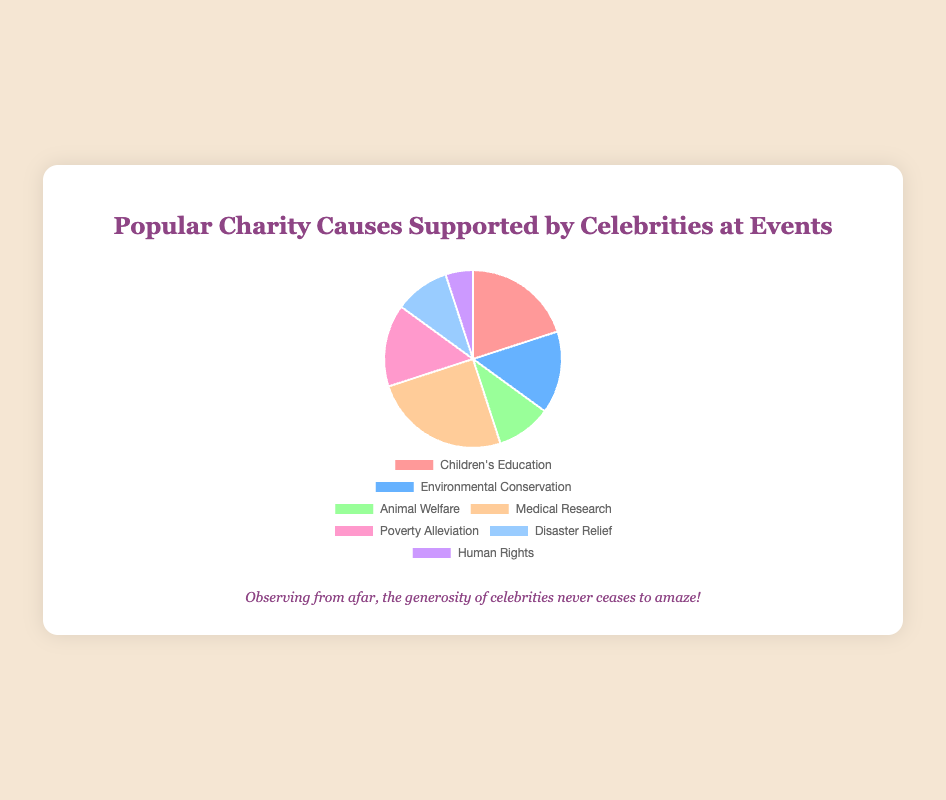Which cause receives the highest percentage of support? By looking at the pie chart, we can see that "Medical Research" has the largest slice, indicating it is the most supported cause at 25%.
Answer: Medical Research Which cause receives the lowest percentage of support? The smallest slice in the pie chart represents "Human Rights" with a support percentage of 5%.
Answer: Human Rights What is the combined support percentage for Environmental Conservation and Poverty Alleviation? To find the combined support percentage, we add 15% for Environmental Conservation and 15% for Poverty Alleviation: 15% + 15% = 30%.
Answer: 30% How does the support for Children's Education compare to that for Animal Welfare? Children's Education has a support percentage of 20%, whereas Animal Welfare has 10%. Thus, Children's Education receives double the support compared to Animal Welfare.
Answer: Twice as much If you were to remove Medical Research from the chart, what would be the new total percentage for the remaining causes? Removing Medical Research, which has 25%, from the total 100% leaves us with: 100% - 25% = 75%.
Answer: 75% Which two causes have the same percentage of support? The pie chart shows that both Environmental Conservation and Poverty Alleviation have a support percentage of 15%.
Answer: Environmental Conservation and Poverty Alleviation What is the difference in support percentage between Disaster Relief and Human Rights? Disaster Relief has 10% while Human Rights has 5%, so the difference is: 10% - 5% = 5%.
Answer: 5% What percentage of support does all the causes related to health (Medical Research and Poverty Alleviation) receive altogether? Combining Medical Research (25%) and Poverty Alleviation (15%): 25% + 15% = 40%.
Answer: 40% What color represents the Animal Welfare cause on the pie chart? The Animal Welfare section is represented by a green color on the pie chart.
Answer: Green How many causes receive support of 10% or less? Both Animal Welfare and Disaster Relief each receive 10%, whereas Human Rights gets 5%. Thus, three causes receive 10% or less.
Answer: 3 